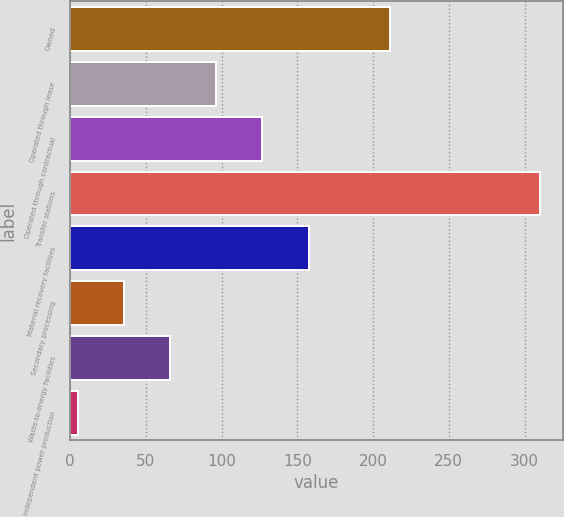<chart> <loc_0><loc_0><loc_500><loc_500><bar_chart><fcel>Owned<fcel>Operated through lease<fcel>Operated through contractual<fcel>Transfer stations<fcel>Material recovery facilities<fcel>Secondary processing<fcel>Waste-to-energy facilities<fcel>Independent power production<nl><fcel>211<fcel>96.5<fcel>127<fcel>310<fcel>157.5<fcel>35.5<fcel>66<fcel>5<nl></chart> 